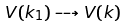<formula> <loc_0><loc_0><loc_500><loc_500>V ( k _ { 1 } ) \dashrightarrow V ( k )</formula> 